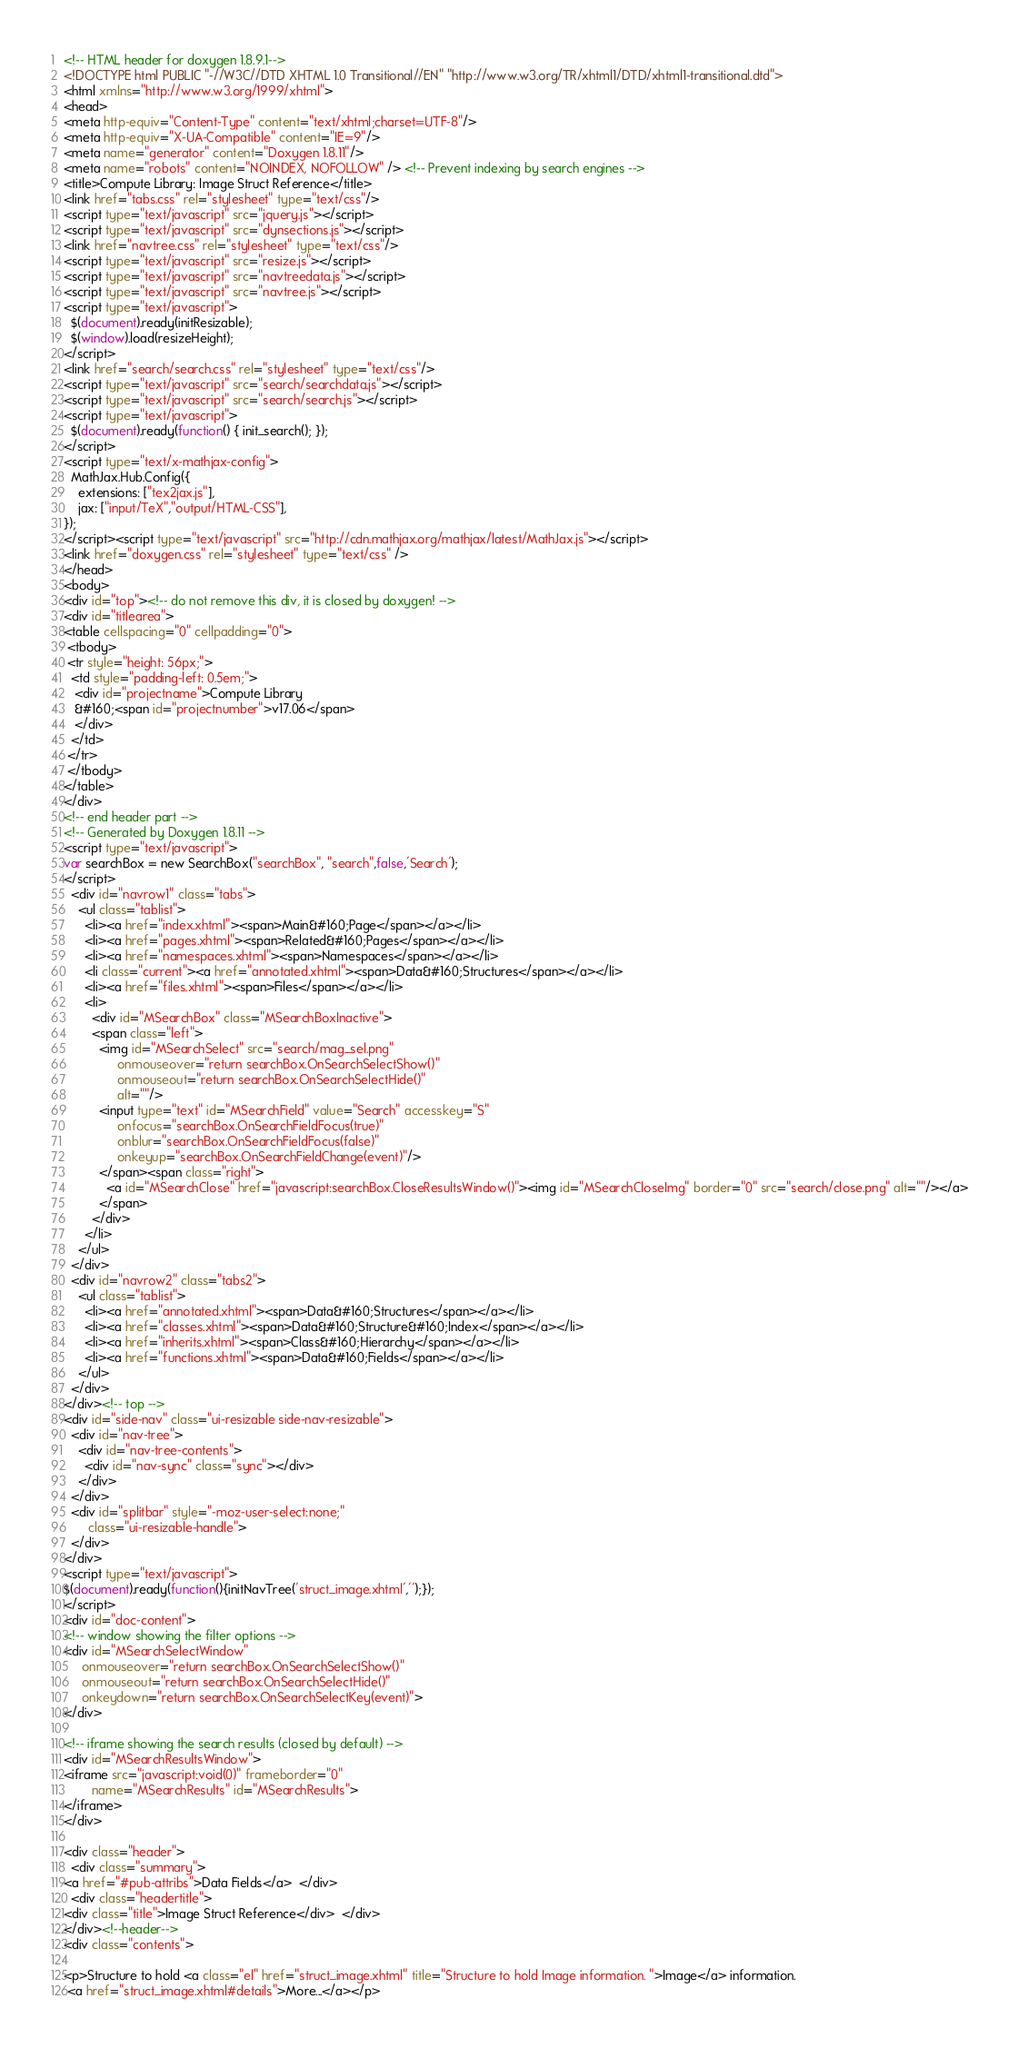Convert code to text. <code><loc_0><loc_0><loc_500><loc_500><_HTML_><!-- HTML header for doxygen 1.8.9.1-->
<!DOCTYPE html PUBLIC "-//W3C//DTD XHTML 1.0 Transitional//EN" "http://www.w3.org/TR/xhtml1/DTD/xhtml1-transitional.dtd">
<html xmlns="http://www.w3.org/1999/xhtml">
<head>
<meta http-equiv="Content-Type" content="text/xhtml;charset=UTF-8"/>
<meta http-equiv="X-UA-Compatible" content="IE=9"/>
<meta name="generator" content="Doxygen 1.8.11"/>
<meta name="robots" content="NOINDEX, NOFOLLOW" /> <!-- Prevent indexing by search engines -->
<title>Compute Library: Image Struct Reference</title>
<link href="tabs.css" rel="stylesheet" type="text/css"/>
<script type="text/javascript" src="jquery.js"></script>
<script type="text/javascript" src="dynsections.js"></script>
<link href="navtree.css" rel="stylesheet" type="text/css"/>
<script type="text/javascript" src="resize.js"></script>
<script type="text/javascript" src="navtreedata.js"></script>
<script type="text/javascript" src="navtree.js"></script>
<script type="text/javascript">
  $(document).ready(initResizable);
  $(window).load(resizeHeight);
</script>
<link href="search/search.css" rel="stylesheet" type="text/css"/>
<script type="text/javascript" src="search/searchdata.js"></script>
<script type="text/javascript" src="search/search.js"></script>
<script type="text/javascript">
  $(document).ready(function() { init_search(); });
</script>
<script type="text/x-mathjax-config">
  MathJax.Hub.Config({
    extensions: ["tex2jax.js"],
    jax: ["input/TeX","output/HTML-CSS"],
});
</script><script type="text/javascript" src="http://cdn.mathjax.org/mathjax/latest/MathJax.js"></script>
<link href="doxygen.css" rel="stylesheet" type="text/css" />
</head>
<body>
<div id="top"><!-- do not remove this div, it is closed by doxygen! -->
<div id="titlearea">
<table cellspacing="0" cellpadding="0">
 <tbody>
 <tr style="height: 56px;">
  <td style="padding-left: 0.5em;">
   <div id="projectname">Compute Library
   &#160;<span id="projectnumber">v17.06</span>
   </div>
  </td>
 </tr>
 </tbody>
</table>
</div>
<!-- end header part -->
<!-- Generated by Doxygen 1.8.11 -->
<script type="text/javascript">
var searchBox = new SearchBox("searchBox", "search",false,'Search');
</script>
  <div id="navrow1" class="tabs">
    <ul class="tablist">
      <li><a href="index.xhtml"><span>Main&#160;Page</span></a></li>
      <li><a href="pages.xhtml"><span>Related&#160;Pages</span></a></li>
      <li><a href="namespaces.xhtml"><span>Namespaces</span></a></li>
      <li class="current"><a href="annotated.xhtml"><span>Data&#160;Structures</span></a></li>
      <li><a href="files.xhtml"><span>Files</span></a></li>
      <li>
        <div id="MSearchBox" class="MSearchBoxInactive">
        <span class="left">
          <img id="MSearchSelect" src="search/mag_sel.png"
               onmouseover="return searchBox.OnSearchSelectShow()"
               onmouseout="return searchBox.OnSearchSelectHide()"
               alt=""/>
          <input type="text" id="MSearchField" value="Search" accesskey="S"
               onfocus="searchBox.OnSearchFieldFocus(true)" 
               onblur="searchBox.OnSearchFieldFocus(false)" 
               onkeyup="searchBox.OnSearchFieldChange(event)"/>
          </span><span class="right">
            <a id="MSearchClose" href="javascript:searchBox.CloseResultsWindow()"><img id="MSearchCloseImg" border="0" src="search/close.png" alt=""/></a>
          </span>
        </div>
      </li>
    </ul>
  </div>
  <div id="navrow2" class="tabs2">
    <ul class="tablist">
      <li><a href="annotated.xhtml"><span>Data&#160;Structures</span></a></li>
      <li><a href="classes.xhtml"><span>Data&#160;Structure&#160;Index</span></a></li>
      <li><a href="inherits.xhtml"><span>Class&#160;Hierarchy</span></a></li>
      <li><a href="functions.xhtml"><span>Data&#160;Fields</span></a></li>
    </ul>
  </div>
</div><!-- top -->
<div id="side-nav" class="ui-resizable side-nav-resizable">
  <div id="nav-tree">
    <div id="nav-tree-contents">
      <div id="nav-sync" class="sync"></div>
    </div>
  </div>
  <div id="splitbar" style="-moz-user-select:none;" 
       class="ui-resizable-handle">
  </div>
</div>
<script type="text/javascript">
$(document).ready(function(){initNavTree('struct_image.xhtml','');});
</script>
<div id="doc-content">
<!-- window showing the filter options -->
<div id="MSearchSelectWindow"
     onmouseover="return searchBox.OnSearchSelectShow()"
     onmouseout="return searchBox.OnSearchSelectHide()"
     onkeydown="return searchBox.OnSearchSelectKey(event)">
</div>

<!-- iframe showing the search results (closed by default) -->
<div id="MSearchResultsWindow">
<iframe src="javascript:void(0)" frameborder="0" 
        name="MSearchResults" id="MSearchResults">
</iframe>
</div>

<div class="header">
  <div class="summary">
<a href="#pub-attribs">Data Fields</a>  </div>
  <div class="headertitle">
<div class="title">Image Struct Reference</div>  </div>
</div><!--header-->
<div class="contents">

<p>Structure to hold <a class="el" href="struct_image.xhtml" title="Structure to hold Image information. ">Image</a> information.  
 <a href="struct_image.xhtml#details">More...</a></p>
</code> 